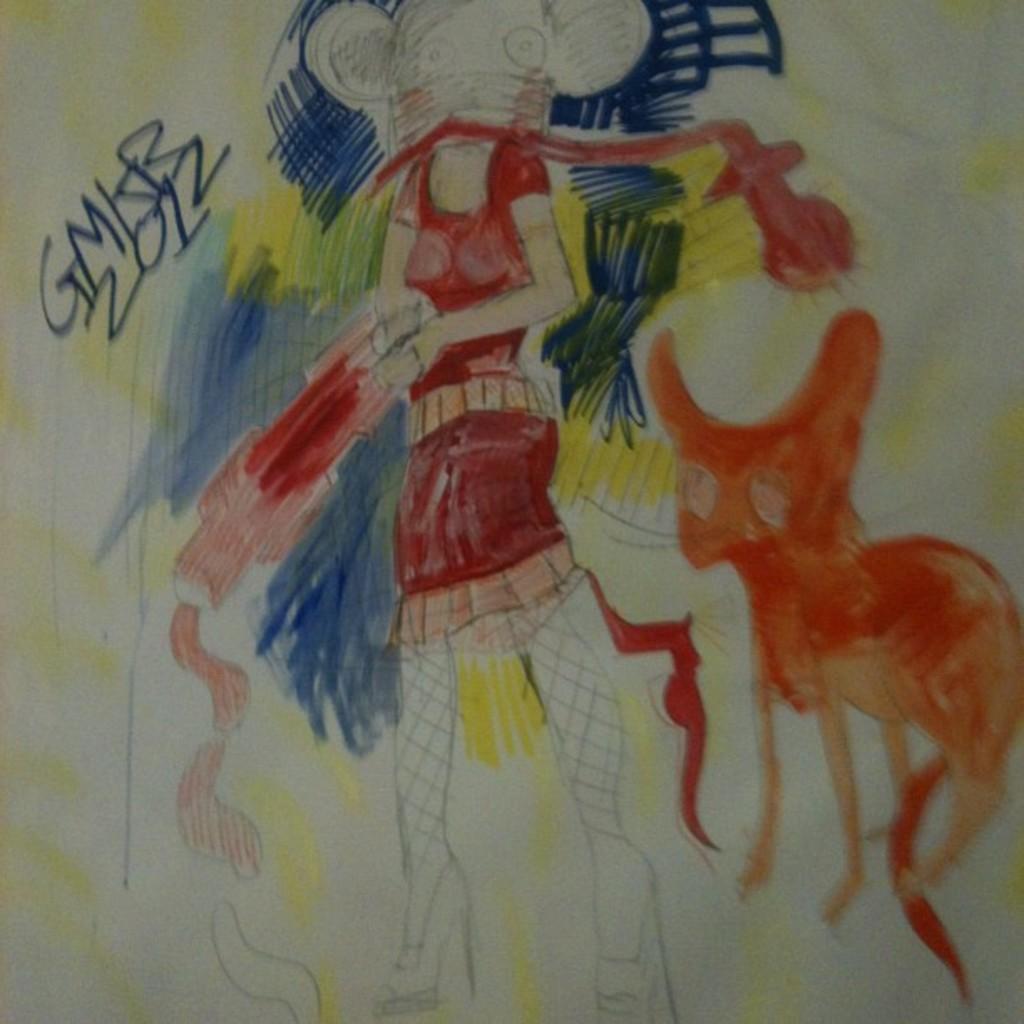In one or two sentences, can you explain what this image depicts? In this image there is a drawing, there is a woman standing, she is holding an object, there is an animal towards the right of the image, there is text, there are numbers, the background of the image is white in color. 